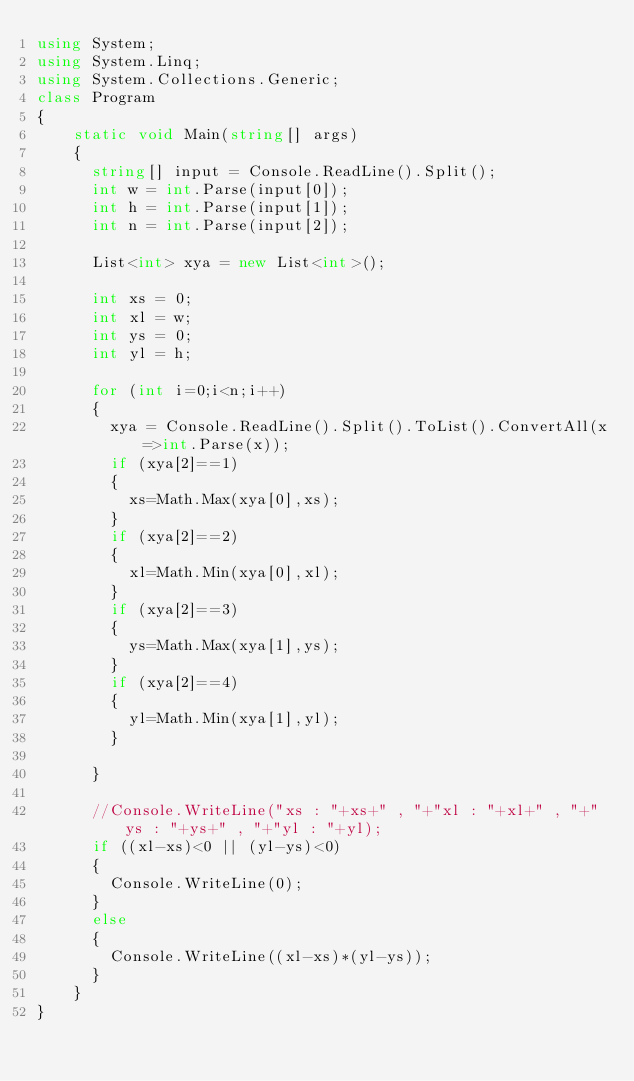<code> <loc_0><loc_0><loc_500><loc_500><_C#_>using System;
using System.Linq;
using System.Collections.Generic;
class Program
{
    static void Main(string[] args)
    {
      string[] input = Console.ReadLine().Split();
      int w = int.Parse(input[0]);
      int h = int.Parse(input[1]);
      int n = int.Parse(input[2]);
      
      List<int> xya = new List<int>();
      
      int xs = 0;
      int xl = w;
      int ys = 0;
      int yl = h;
      
      for (int i=0;i<n;i++)
      {
        xya = Console.ReadLine().Split().ToList().ConvertAll(x=>int.Parse(x));
        if (xya[2]==1)
        {
          xs=Math.Max(xya[0],xs);
        }
        if (xya[2]==2)
        {
          xl=Math.Min(xya[0],xl);
        }
        if (xya[2]==3)
        {
          ys=Math.Max(xya[1],ys);
        }
        if (xya[2]==4)
        {
          yl=Math.Min(xya[1],yl);
        }       
        
      }
      
      //Console.WriteLine("xs : "+xs+" , "+"xl : "+xl+" , "+"ys : "+ys+" , "+"yl : "+yl);
      if ((xl-xs)<0 || (yl-ys)<0)
      {
        Console.WriteLine(0);
      }
      else
      {
        Console.WriteLine((xl-xs)*(yl-ys));
      }
    }
}
</code> 